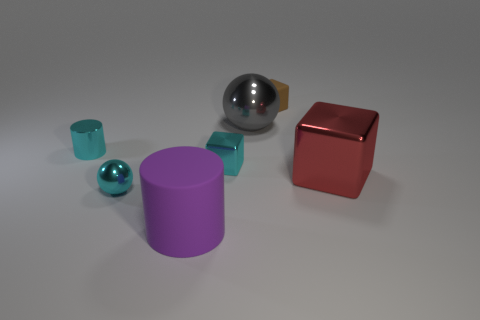Is there any other thing that is the same shape as the gray thing?
Provide a succinct answer. Yes. Are there any gray metal things?
Offer a very short reply. Yes. Is the number of cylinders less than the number of small cyan shiny cylinders?
Give a very brief answer. No. How many cyan balls are the same material as the large red block?
Your response must be concise. 1. There is another ball that is the same material as the cyan sphere; what is its color?
Your response must be concise. Gray. What is the shape of the gray metal object?
Make the answer very short. Sphere. What number of small spheres are the same color as the large cylinder?
Give a very brief answer. 0. There is a gray metal object that is the same size as the purple thing; what is its shape?
Make the answer very short. Sphere. Are there any brown metal cylinders of the same size as the brown object?
Give a very brief answer. No. What material is the purple object that is the same size as the red block?
Your answer should be compact. Rubber. 